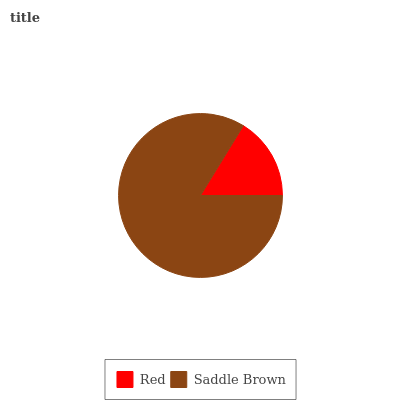Is Red the minimum?
Answer yes or no. Yes. Is Saddle Brown the maximum?
Answer yes or no. Yes. Is Saddle Brown the minimum?
Answer yes or no. No. Is Saddle Brown greater than Red?
Answer yes or no. Yes. Is Red less than Saddle Brown?
Answer yes or no. Yes. Is Red greater than Saddle Brown?
Answer yes or no. No. Is Saddle Brown less than Red?
Answer yes or no. No. Is Saddle Brown the high median?
Answer yes or no. Yes. Is Red the low median?
Answer yes or no. Yes. Is Red the high median?
Answer yes or no. No. Is Saddle Brown the low median?
Answer yes or no. No. 